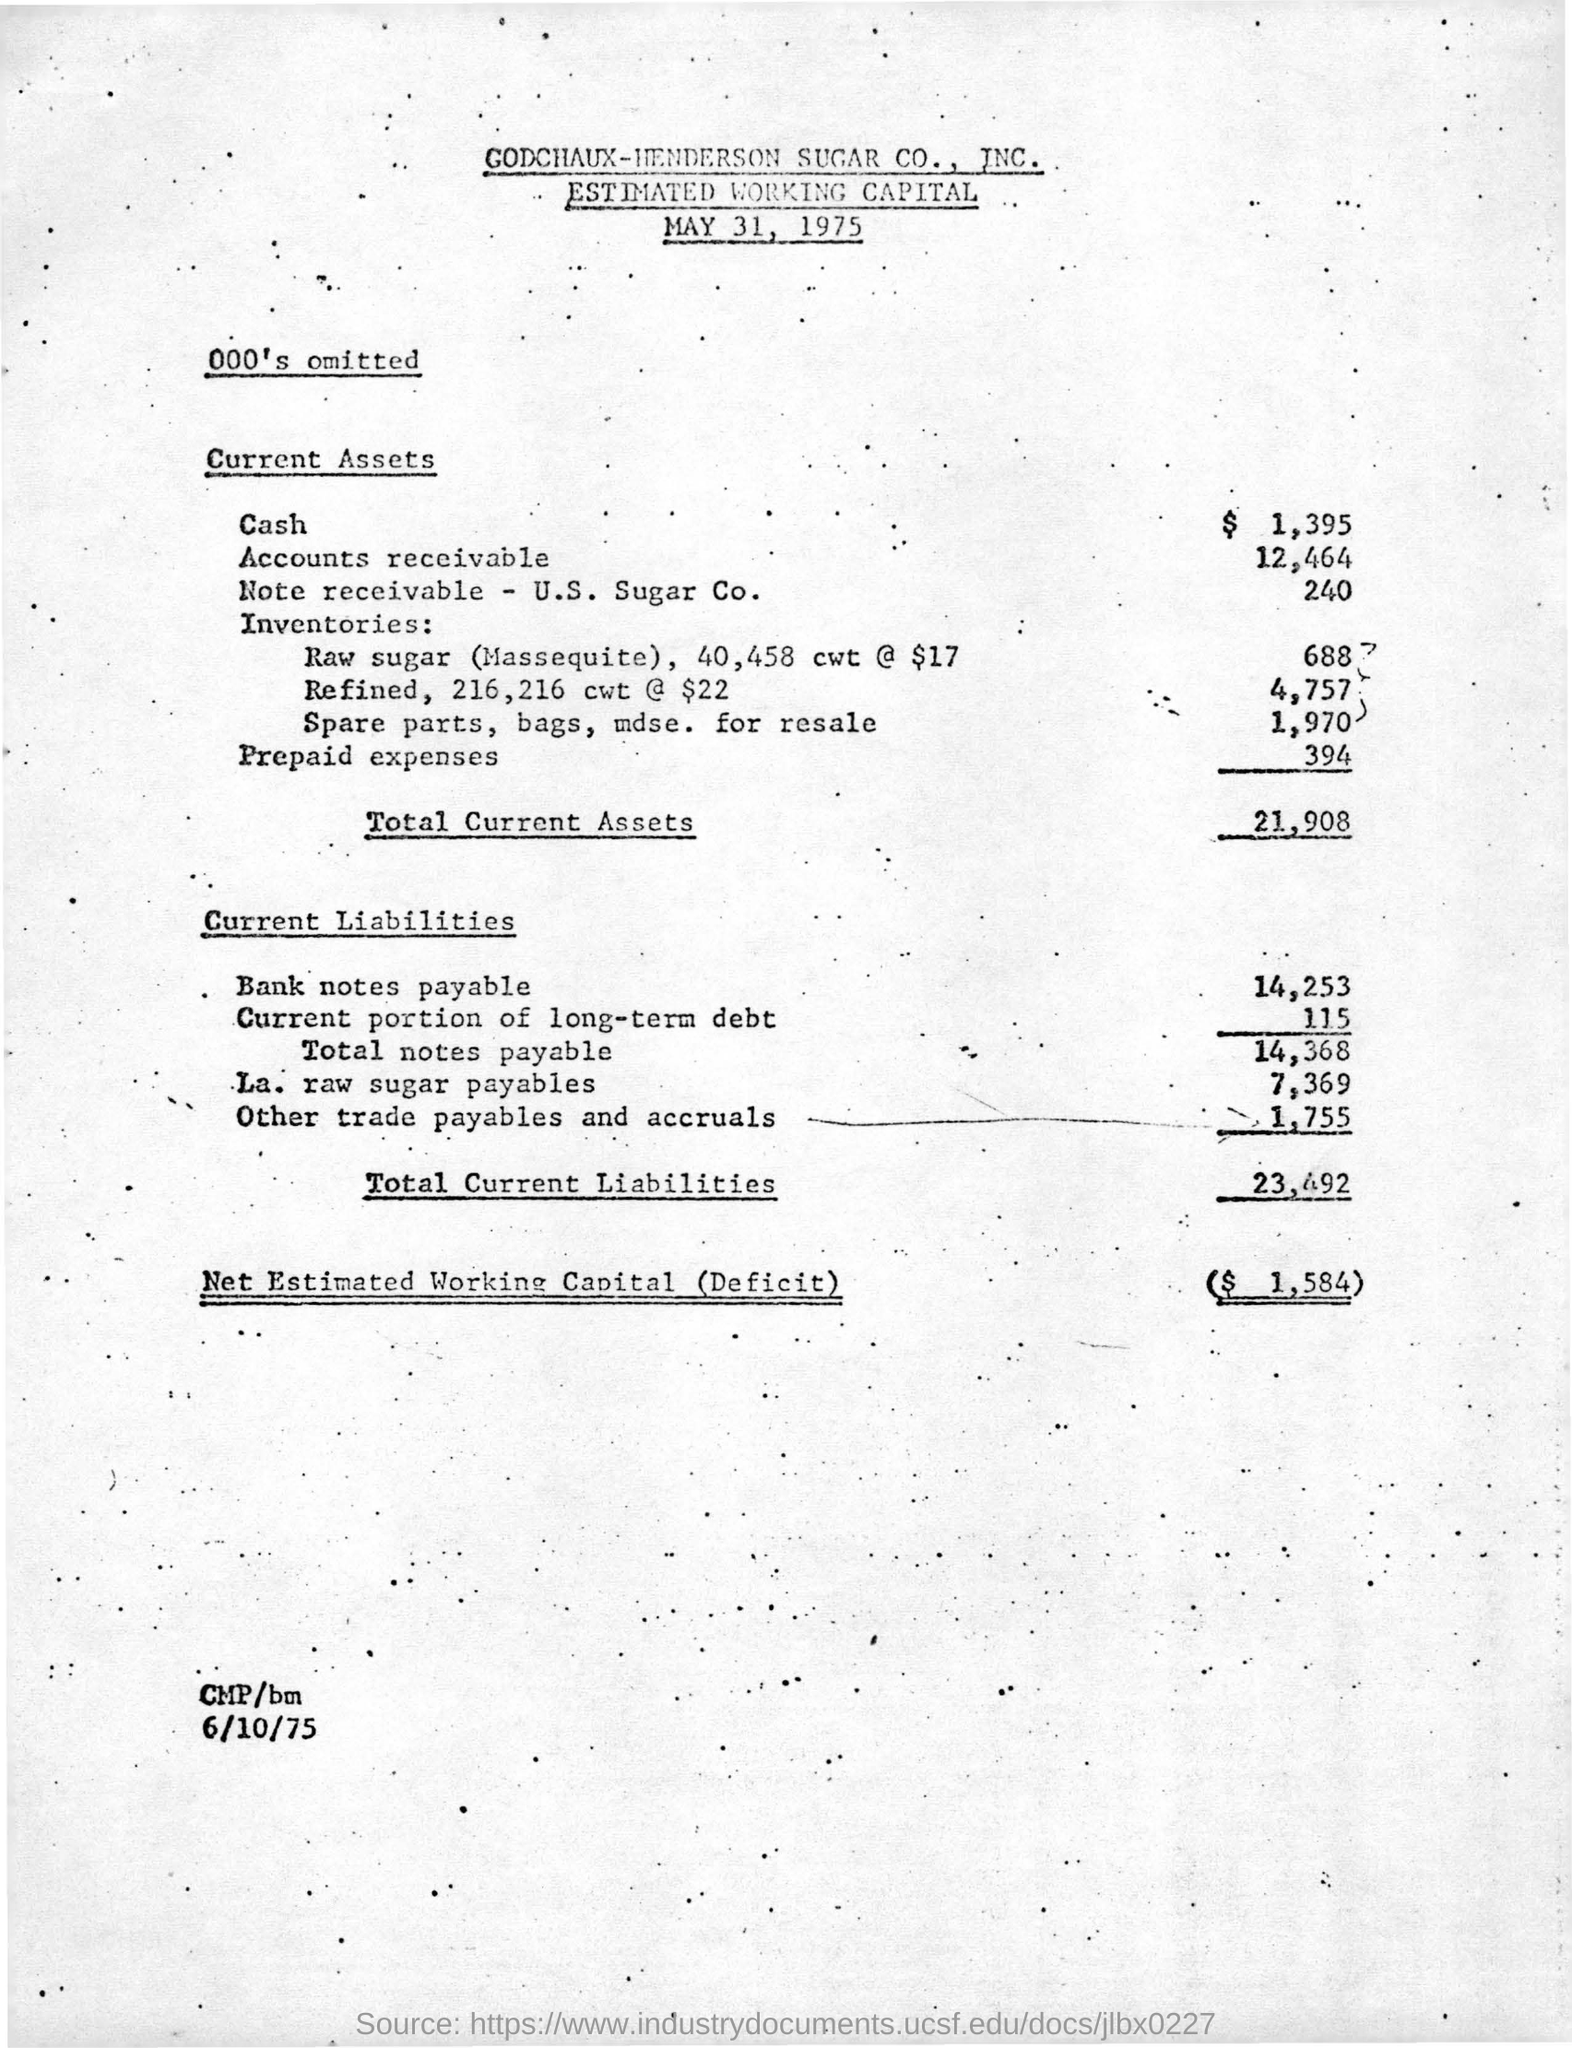How much is the total current assets in the given form?
Ensure brevity in your answer.  21,908. In which year this estimated working capital is released ?
Make the answer very short. 1975. What is the amount of prepaid expenses in the current assets ?
Your answer should be very brief. 394. What is the amount of  net estimated working capital (deficit) ?
Give a very brief answer. ($  1,584). What is the amount of total current liabilities ?
Your answer should be compact. 23,492. What is the value of other trade payables and accruals in the current liabilities ?
Provide a short and direct response. 1,755. 